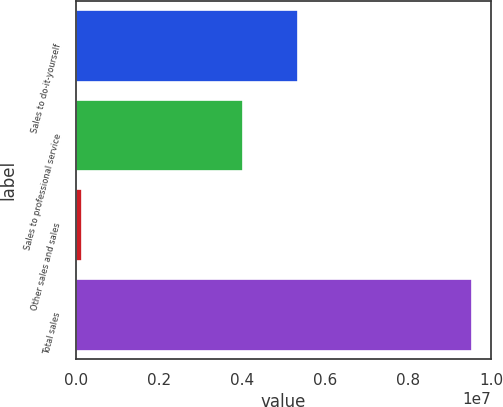<chart> <loc_0><loc_0><loc_500><loc_500><bar_chart><fcel>Sales to do-it-yourself<fcel>Sales to professional service<fcel>Other sales and sales<fcel>Total sales<nl><fcel>5.35104e+06<fcel>4.0359e+06<fcel>149495<fcel>9.53643e+06<nl></chart> 